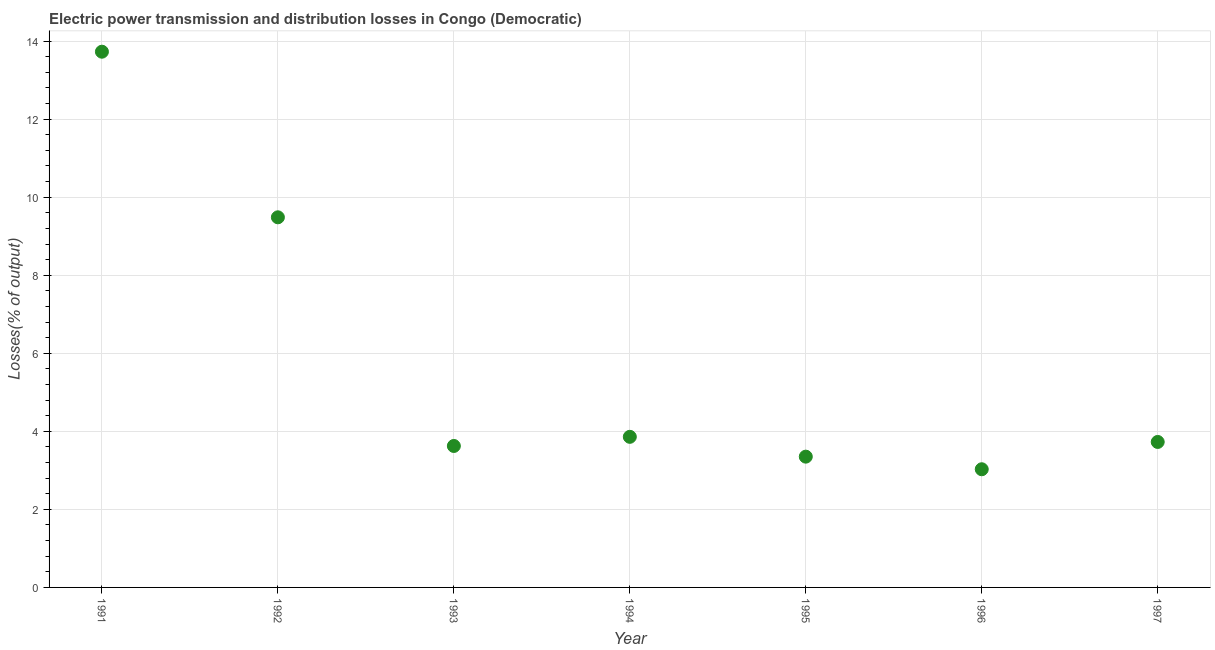What is the electric power transmission and distribution losses in 1991?
Your answer should be compact. 13.73. Across all years, what is the maximum electric power transmission and distribution losses?
Offer a terse response. 13.73. Across all years, what is the minimum electric power transmission and distribution losses?
Your answer should be very brief. 3.03. In which year was the electric power transmission and distribution losses maximum?
Keep it short and to the point. 1991. What is the sum of the electric power transmission and distribution losses?
Provide a succinct answer. 40.8. What is the difference between the electric power transmission and distribution losses in 1994 and 1996?
Keep it short and to the point. 0.83. What is the average electric power transmission and distribution losses per year?
Provide a succinct answer. 5.83. What is the median electric power transmission and distribution losses?
Your response must be concise. 3.73. In how many years, is the electric power transmission and distribution losses greater than 13.2 %?
Provide a short and direct response. 1. What is the ratio of the electric power transmission and distribution losses in 1993 to that in 1997?
Keep it short and to the point. 0.97. Is the difference between the electric power transmission and distribution losses in 1995 and 1997 greater than the difference between any two years?
Provide a succinct answer. No. What is the difference between the highest and the second highest electric power transmission and distribution losses?
Give a very brief answer. 4.24. What is the difference between the highest and the lowest electric power transmission and distribution losses?
Keep it short and to the point. 10.7. Does the graph contain any zero values?
Your answer should be very brief. No. Does the graph contain grids?
Offer a very short reply. Yes. What is the title of the graph?
Your answer should be compact. Electric power transmission and distribution losses in Congo (Democratic). What is the label or title of the Y-axis?
Make the answer very short. Losses(% of output). What is the Losses(% of output) in 1991?
Offer a very short reply. 13.73. What is the Losses(% of output) in 1992?
Provide a succinct answer. 9.48. What is the Losses(% of output) in 1993?
Your answer should be compact. 3.62. What is the Losses(% of output) in 1994?
Your answer should be very brief. 3.86. What is the Losses(% of output) in 1995?
Your answer should be compact. 3.35. What is the Losses(% of output) in 1996?
Your answer should be compact. 3.03. What is the Losses(% of output) in 1997?
Your answer should be compact. 3.73. What is the difference between the Losses(% of output) in 1991 and 1992?
Offer a terse response. 4.24. What is the difference between the Losses(% of output) in 1991 and 1993?
Provide a short and direct response. 10.1. What is the difference between the Losses(% of output) in 1991 and 1994?
Offer a very short reply. 9.87. What is the difference between the Losses(% of output) in 1991 and 1995?
Make the answer very short. 10.38. What is the difference between the Losses(% of output) in 1991 and 1996?
Provide a succinct answer. 10.7. What is the difference between the Losses(% of output) in 1991 and 1997?
Provide a succinct answer. 10. What is the difference between the Losses(% of output) in 1992 and 1993?
Your response must be concise. 5.86. What is the difference between the Losses(% of output) in 1992 and 1994?
Give a very brief answer. 5.63. What is the difference between the Losses(% of output) in 1992 and 1995?
Provide a short and direct response. 6.13. What is the difference between the Losses(% of output) in 1992 and 1996?
Offer a very short reply. 6.46. What is the difference between the Losses(% of output) in 1992 and 1997?
Offer a terse response. 5.76. What is the difference between the Losses(% of output) in 1993 and 1994?
Your answer should be compact. -0.23. What is the difference between the Losses(% of output) in 1993 and 1995?
Ensure brevity in your answer.  0.27. What is the difference between the Losses(% of output) in 1993 and 1996?
Offer a very short reply. 0.6. What is the difference between the Losses(% of output) in 1993 and 1997?
Your answer should be compact. -0.1. What is the difference between the Losses(% of output) in 1994 and 1995?
Keep it short and to the point. 0.51. What is the difference between the Losses(% of output) in 1994 and 1996?
Your answer should be compact. 0.83. What is the difference between the Losses(% of output) in 1994 and 1997?
Offer a terse response. 0.13. What is the difference between the Losses(% of output) in 1995 and 1996?
Your answer should be compact. 0.32. What is the difference between the Losses(% of output) in 1995 and 1997?
Keep it short and to the point. -0.38. What is the difference between the Losses(% of output) in 1996 and 1997?
Make the answer very short. -0.7. What is the ratio of the Losses(% of output) in 1991 to that in 1992?
Ensure brevity in your answer.  1.45. What is the ratio of the Losses(% of output) in 1991 to that in 1993?
Offer a terse response. 3.79. What is the ratio of the Losses(% of output) in 1991 to that in 1994?
Give a very brief answer. 3.56. What is the ratio of the Losses(% of output) in 1991 to that in 1995?
Your answer should be very brief. 4.1. What is the ratio of the Losses(% of output) in 1991 to that in 1996?
Provide a succinct answer. 4.53. What is the ratio of the Losses(% of output) in 1991 to that in 1997?
Your response must be concise. 3.68. What is the ratio of the Losses(% of output) in 1992 to that in 1993?
Give a very brief answer. 2.62. What is the ratio of the Losses(% of output) in 1992 to that in 1994?
Offer a very short reply. 2.46. What is the ratio of the Losses(% of output) in 1992 to that in 1995?
Offer a terse response. 2.83. What is the ratio of the Losses(% of output) in 1992 to that in 1996?
Your response must be concise. 3.13. What is the ratio of the Losses(% of output) in 1992 to that in 1997?
Offer a terse response. 2.54. What is the ratio of the Losses(% of output) in 1993 to that in 1994?
Provide a succinct answer. 0.94. What is the ratio of the Losses(% of output) in 1993 to that in 1995?
Keep it short and to the point. 1.08. What is the ratio of the Losses(% of output) in 1993 to that in 1996?
Your response must be concise. 1.2. What is the ratio of the Losses(% of output) in 1994 to that in 1995?
Keep it short and to the point. 1.15. What is the ratio of the Losses(% of output) in 1994 to that in 1996?
Your answer should be compact. 1.27. What is the ratio of the Losses(% of output) in 1994 to that in 1997?
Keep it short and to the point. 1.03. What is the ratio of the Losses(% of output) in 1995 to that in 1996?
Ensure brevity in your answer.  1.11. What is the ratio of the Losses(% of output) in 1995 to that in 1997?
Your answer should be compact. 0.9. What is the ratio of the Losses(% of output) in 1996 to that in 1997?
Your answer should be compact. 0.81. 